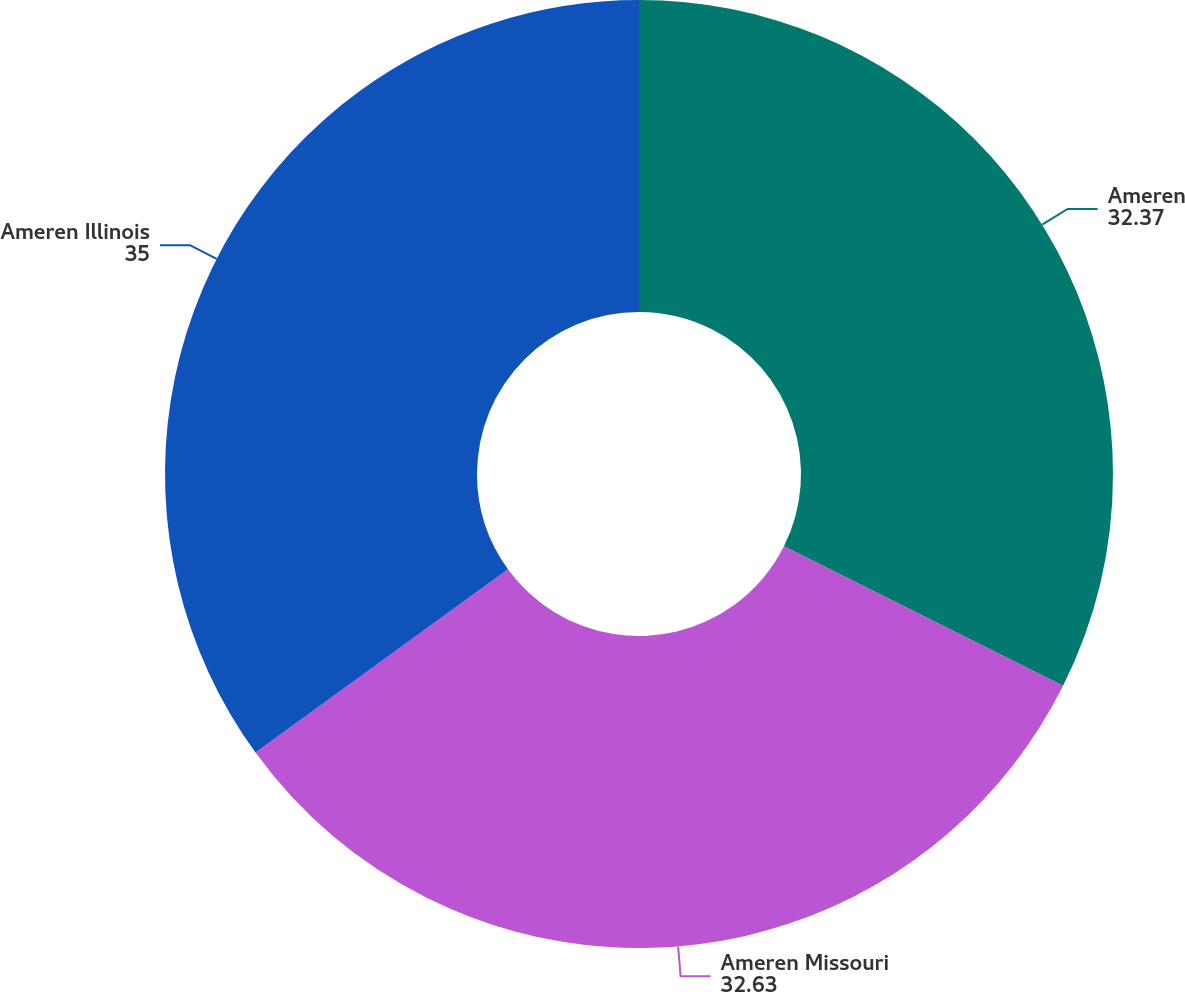<chart> <loc_0><loc_0><loc_500><loc_500><pie_chart><fcel>Ameren<fcel>Ameren Missouri<fcel>Ameren Illinois<nl><fcel>32.37%<fcel>32.63%<fcel>35.0%<nl></chart> 